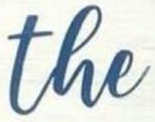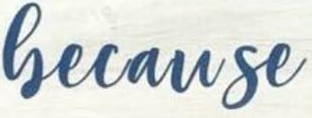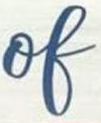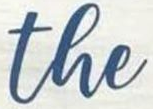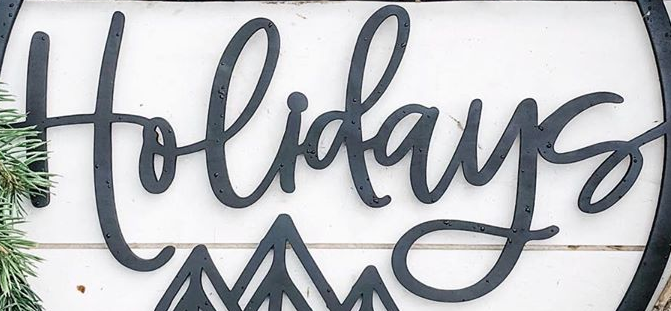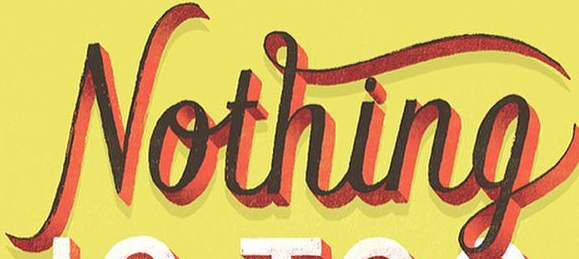What words can you see in these images in sequence, separated by a semicolon? the; Gecause; of; the; Holidays; Nothing 